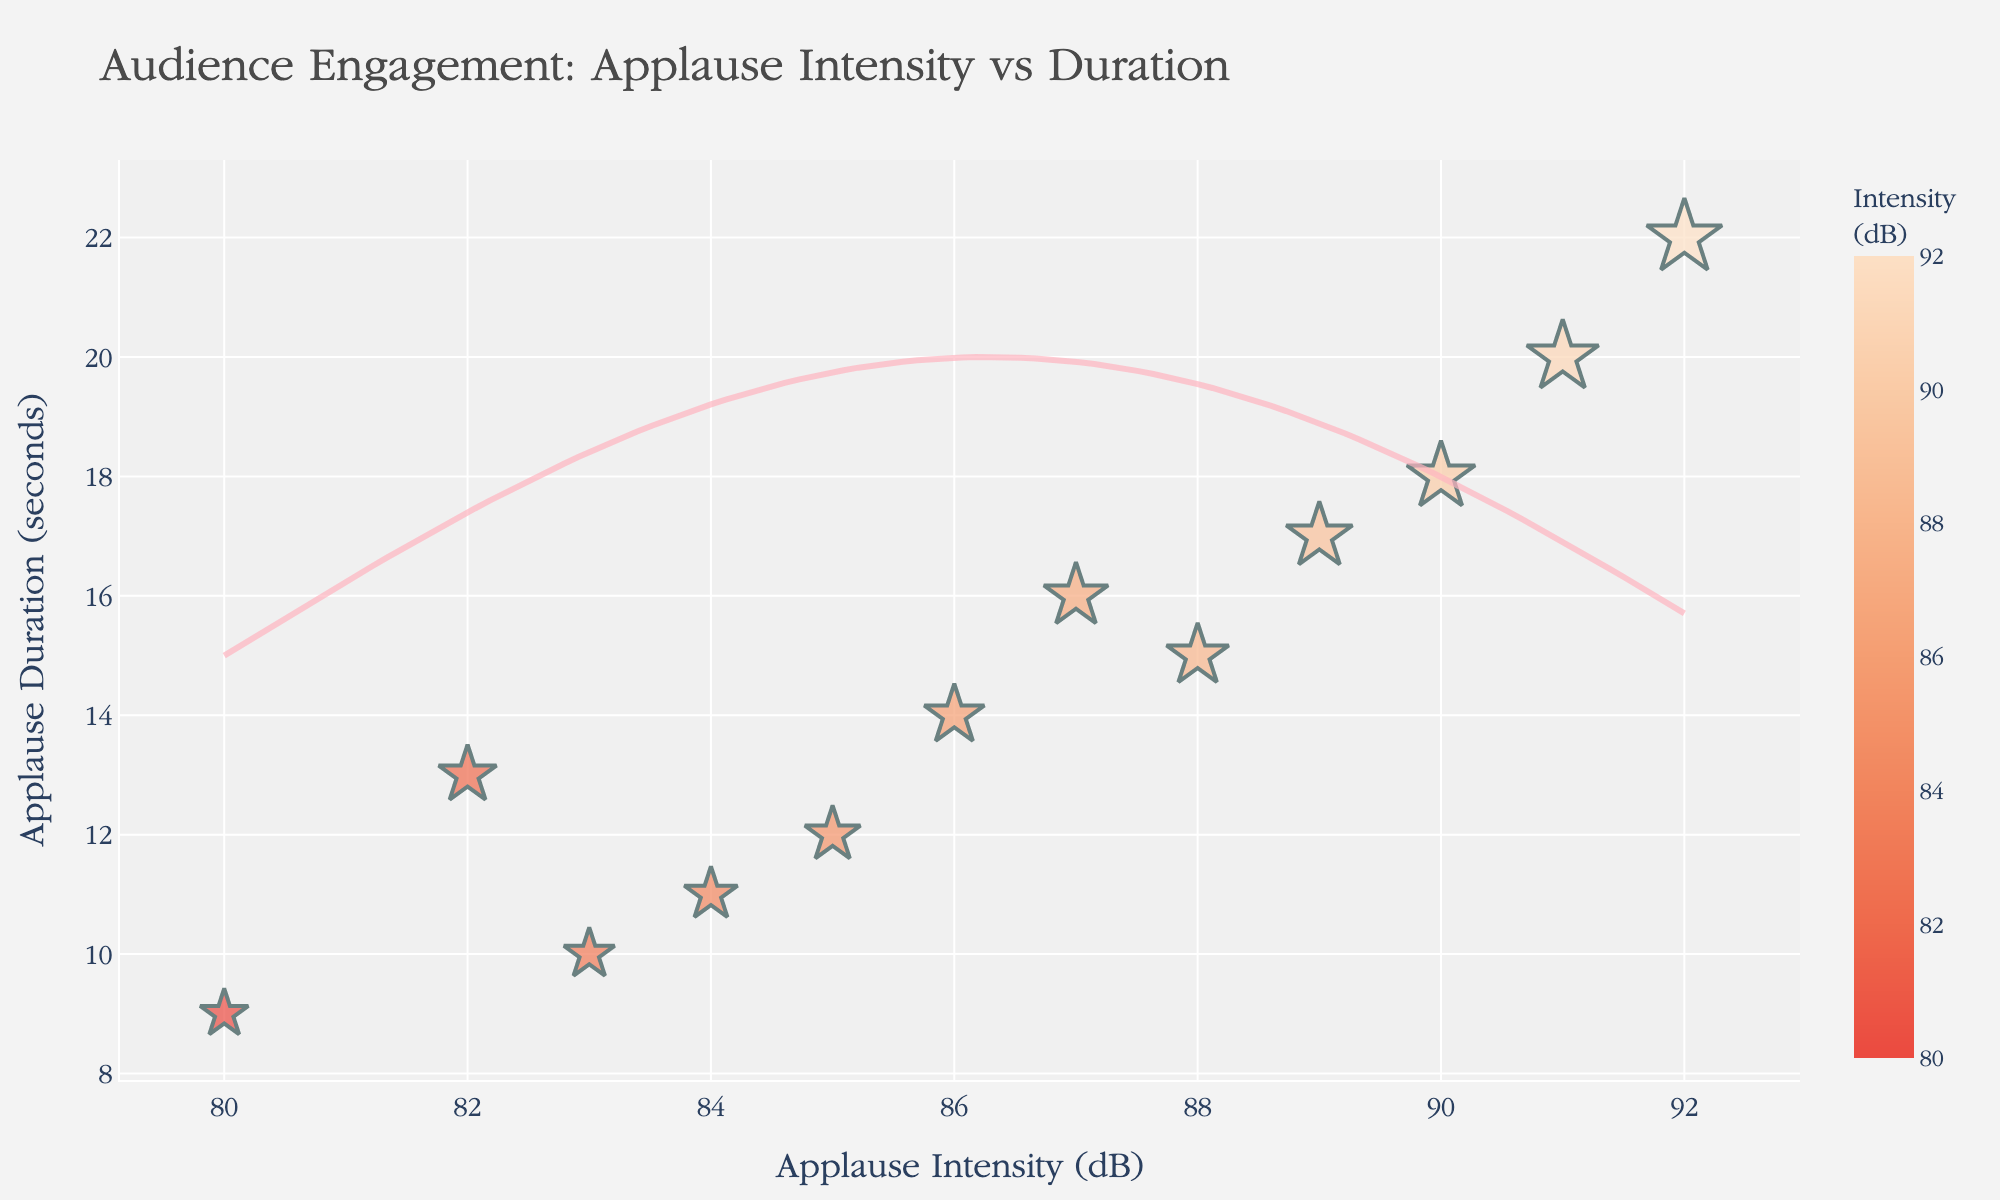How many data points are in the scatter plot? We count each unique performance represented by a unique marker in the scatter plot: Swan Lake A, Swan Lake B, The Nutcracker A, The Nutcracker B, Giselle A, Giselle B, Coppélia A, Coppélia B, Sleeping Beauty A, Sleeping Beauty B, Don Quixote A, and Don Quixote B. That's 12 data points.
Answer: 12 What’s the title of the scatter plot? The title is written at the top of the scatter plot in larger font size, providing a summary of what the plot represents. In this case, it reads "Audience Engagement: Applause Intensity vs Duration."
Answer: Audience Engagement: Applause Intensity vs Duration What are the values for the axis with Applause Duration? The y-axis represents Applause Duration, labeled on the left side of the graph. Visual inspection shows values starting from 0 to 25 seconds.
Answer: 0 to 25 seconds Which performance had the highest applause intensity? By looking for the point that is furthest to the right on the x-axis (Applause Intensity), we identify "Sleeping Beauty A" at 92 dB as the highest.
Answer: Sleeping Beauty A Which performance had the longest applause duration? The point that is highest on the y-axis (Applause Duration) represents the longest duration. This is "Sleeping Beauty A" at 22 seconds.
Answer: Sleeping Beauty A What is the average applause intensity for the Coppélia performances? Locate the data points for Coppélia A (91 dB) and Coppélia B (89 dB). Average these values: (91 + 89) / 2 = 90.
Answer: 90 Are there any performances with both high applause intensity and long duration? Define "high" as above 88 dB and "long" as above 18 seconds. "Sleeping Beauty A" has 92 dB and 22 seconds, and "Coppélia A" has 91 dB and 20 seconds, marking both as high and long.
Answer: Sleeping Beauty A and Coppélia A Which performance had the lowest audience engagement according to the plot? Low engagement can be inferred from low applause intensity and short duration. "Giselle B" with 80 dB and 9 seconds is the lowest combination.
Answer: Giselle B How do the audience engagements of Swan Lake compare to Don Quixote? Compare Swan Lake A (88 dB, 15s) and B (85 dB, 12s) with Don Quixote A (84 dB, 11s) and B (82 dB, 13s). Swan Lake A and B both have higher intensities and longer or similar durations than both Don Quixote performances.
Answer: Higher Is there a trend visible in audience engagement throughout the performances? Envision a general direction in the scatter plot; performances with higher intensities tend to have longer durations, indicating a positive correlation between applause intensity and duration. This is augmented by the fit curve added to the scatter plot.
Answer: Positive correlation 